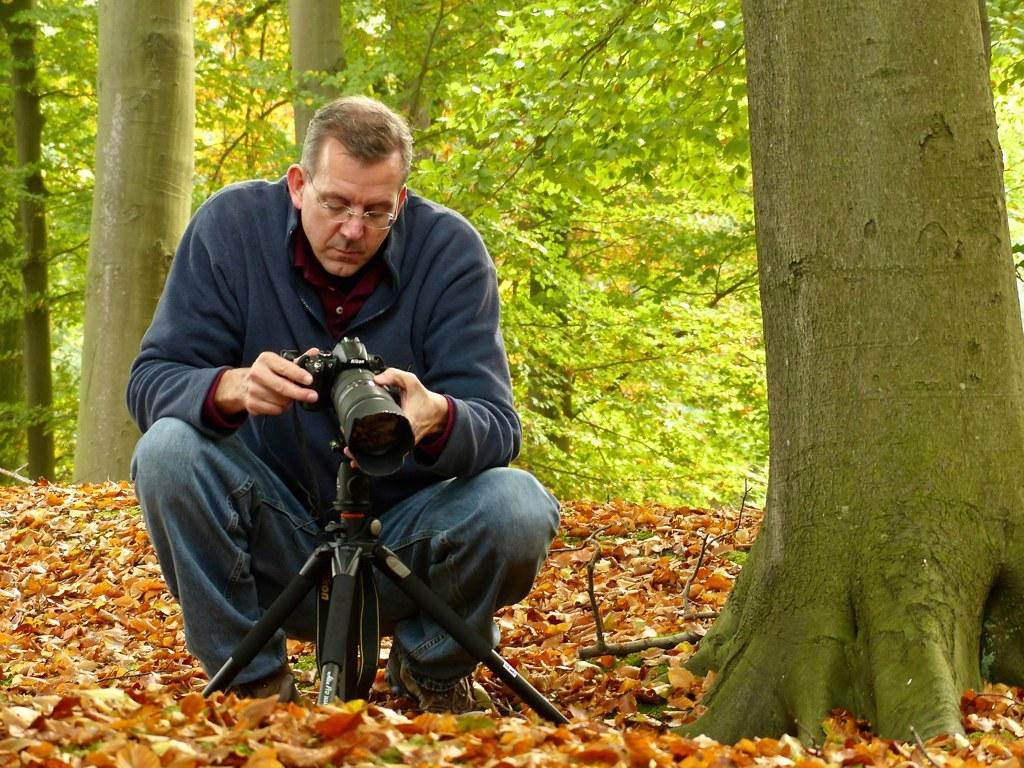What type of natural elements can be seen in the image? There are trees in the image. Who is present in the image? There is a man in the image. What is the man holding in the image? The man is holding a camera. What type of farm animals can be seen in the image? There are no farm animals present in the image; it features trees and a man holding a camera. What type of slave labor is depicted in the image? There is no depiction of slave labor in the image; it features trees, a man holding a camera, and no indication of any labor or work being performed. 